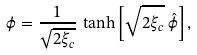Convert formula to latex. <formula><loc_0><loc_0><loc_500><loc_500>\phi = \frac { 1 } { \sqrt { 2 \xi _ { c } } } \, \tanh \left [ \sqrt { 2 \xi _ { c } } \, \hat { \phi } \right ] ,</formula> 